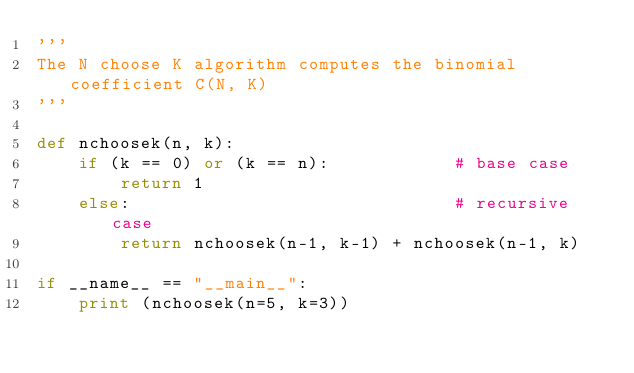Convert code to text. <code><loc_0><loc_0><loc_500><loc_500><_Python_>'''
The N choose K algorithm computes the binomial coefficient C(N, K)
'''

def nchoosek(n, k):
    if (k == 0) or (k == n):            # base case
        return 1
    else:                               # recursive case
        return nchoosek(n-1, k-1) + nchoosek(n-1, k)

if __name__ == "__main__":
    print (nchoosek(n=5, k=3))</code> 